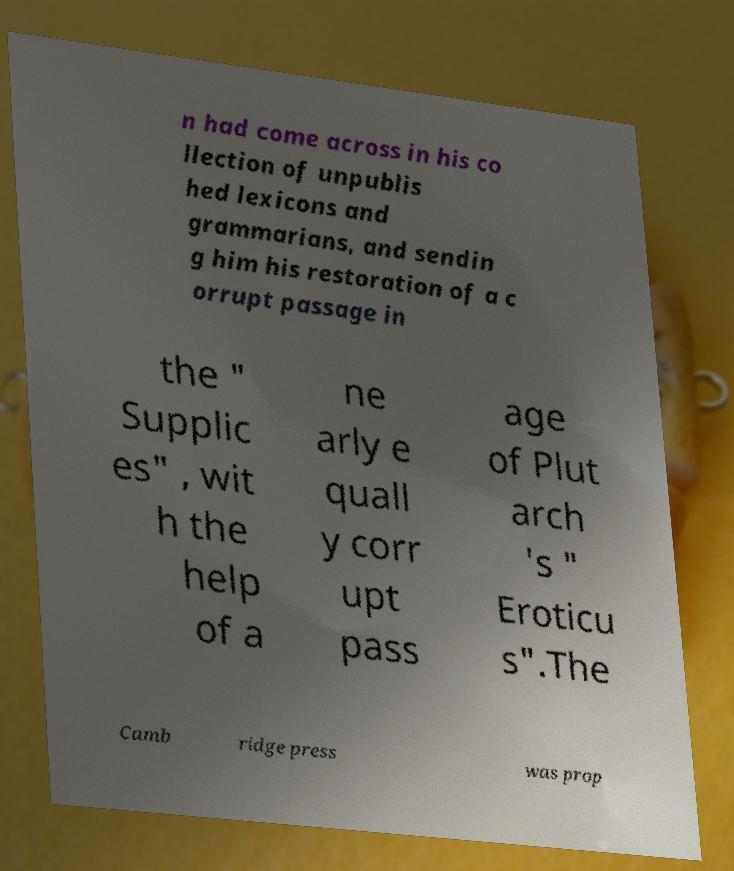I need the written content from this picture converted into text. Can you do that? n had come across in his co llection of unpublis hed lexicons and grammarians, and sendin g him his restoration of a c orrupt passage in the " Supplic es" , wit h the help of a ne arly e quall y corr upt pass age of Plut arch 's " Eroticu s".The Camb ridge press was prop 